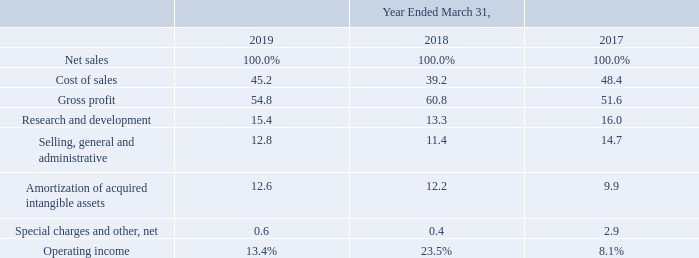Results of Continuing Operations
The following table sets forth certain operational data as a percentage of net sales for the fiscal years indicated:
Which years does the table provide information for certain operational data as a percentage of net sales? 2019, 2018, 2017. What was the percentage of cost of sales of net sales in 2019?
Answer scale should be: percent. 45.2. What was the percentage of gross profit of net sales in 2018?
Answer scale should be: percent. 60.8. What was the percentage change in gross profit of net sales between 2017 and 2018?
Answer scale should be: percent. 60.8-51.6
Answer: 9.2. How many years did cost of sales of net sales exceed 40%? 2019##2017
Answer: 2. What was the percentage change in operating income of net sales between 2018 and 2019?
Answer scale should be: percent. 13.4-23.5
Answer: -10.1. 